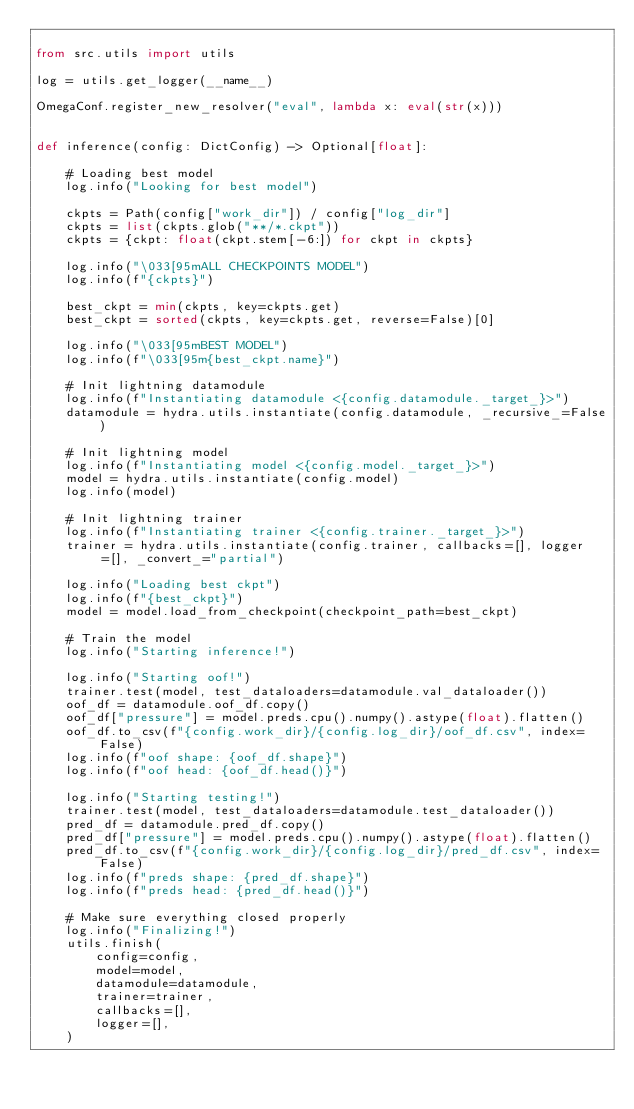<code> <loc_0><loc_0><loc_500><loc_500><_Python_>
from src.utils import utils

log = utils.get_logger(__name__)

OmegaConf.register_new_resolver("eval", lambda x: eval(str(x)))


def inference(config: DictConfig) -> Optional[float]:

    # Loading best model
    log.info("Looking for best model")

    ckpts = Path(config["work_dir"]) / config["log_dir"]
    ckpts = list(ckpts.glob("**/*.ckpt"))
    ckpts = {ckpt: float(ckpt.stem[-6:]) for ckpt in ckpts}

    log.info("\033[95mALL CHECKPOINTS MODEL")
    log.info(f"{ckpts}")

    best_ckpt = min(ckpts, key=ckpts.get)
    best_ckpt = sorted(ckpts, key=ckpts.get, reverse=False)[0]

    log.info("\033[95mBEST MODEL")
    log.info(f"\033[95m{best_ckpt.name}")

    # Init lightning datamodule
    log.info(f"Instantiating datamodule <{config.datamodule._target_}>")
    datamodule = hydra.utils.instantiate(config.datamodule, _recursive_=False)

    # Init lightning model
    log.info(f"Instantiating model <{config.model._target_}>")
    model = hydra.utils.instantiate(config.model)
    log.info(model)

    # Init lightning trainer
    log.info(f"Instantiating trainer <{config.trainer._target_}>")
    trainer = hydra.utils.instantiate(config.trainer, callbacks=[], logger=[], _convert_="partial")

    log.info("Loading best ckpt")
    log.info(f"{best_ckpt}")
    model = model.load_from_checkpoint(checkpoint_path=best_ckpt)

    # Train the model
    log.info("Starting inference!")

    log.info("Starting oof!")
    trainer.test(model, test_dataloaders=datamodule.val_dataloader())
    oof_df = datamodule.oof_df.copy()
    oof_df["pressure"] = model.preds.cpu().numpy().astype(float).flatten()
    oof_df.to_csv(f"{config.work_dir}/{config.log_dir}/oof_df.csv", index=False)
    log.info(f"oof shape: {oof_df.shape}")
    log.info(f"oof head: {oof_df.head()}")

    log.info("Starting testing!")
    trainer.test(model, test_dataloaders=datamodule.test_dataloader())
    pred_df = datamodule.pred_df.copy()
    pred_df["pressure"] = model.preds.cpu().numpy().astype(float).flatten()
    pred_df.to_csv(f"{config.work_dir}/{config.log_dir}/pred_df.csv", index=False)
    log.info(f"preds shape: {pred_df.shape}")
    log.info(f"preds head: {pred_df.head()}")

    # Make sure everything closed properly
    log.info("Finalizing!")
    utils.finish(
        config=config,
        model=model,
        datamodule=datamodule,
        trainer=trainer,
        callbacks=[],
        logger=[],
    )
</code> 